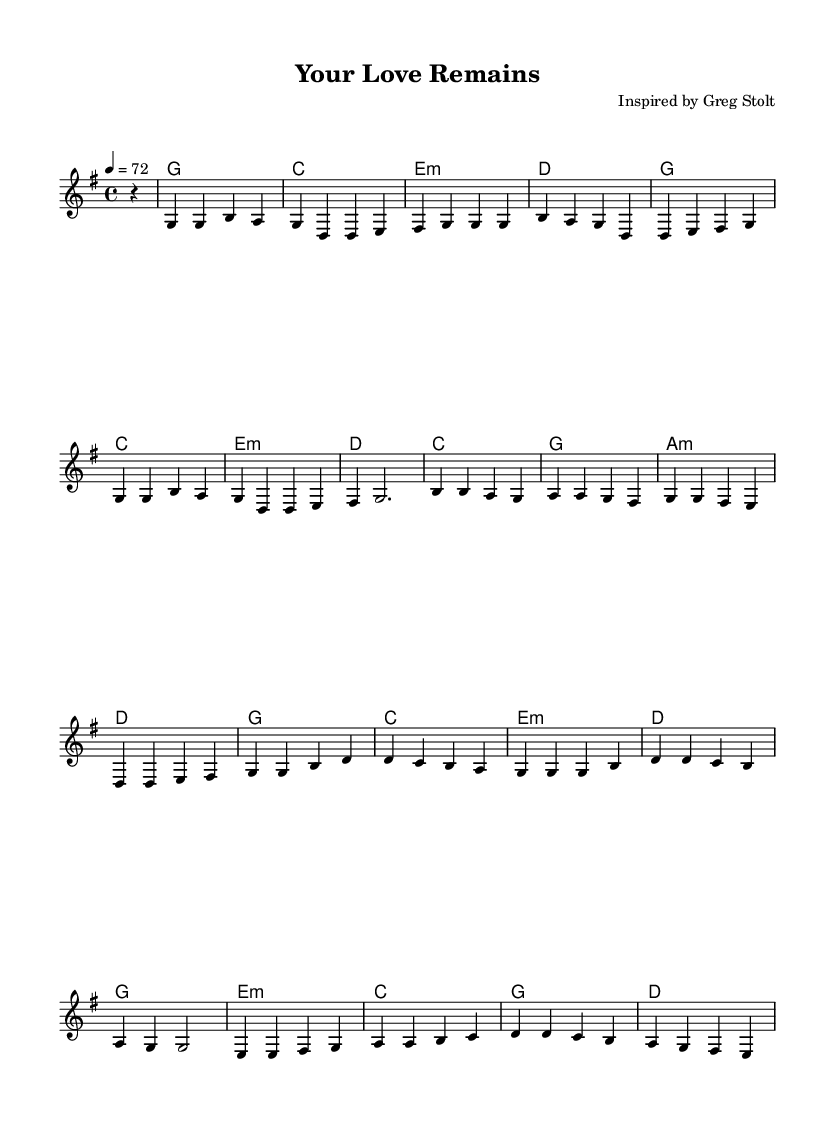What is the key signature of this music? The key signature is indicated at the beginning of the score, which shows that there are no sharps or flats, confirming G major as the key signature.
Answer: G major What is the time signature of this music? The time signature is found next to the key signature, showing the organization of beats in each measure. The numerator (4) indicates that there are four beats per measure, and the denominator (4) indicates that the quarter note gets one beat.
Answer: 4/4 What is the tempo marking for this piece? The tempo marking appears under the global settings and indicates the speed at which the piece should be played. The marking shows that the piece should be played at a pace of 72 beats per minute.
Answer: 72 How many measures are in the verse section? The verse section can be identified by counting the distinct group of musical phrases that fall under the verse markings. After counting, it is determined that there are 8 measures in this section.
Answer: 8 What chord follows the A minor chord in the pre-chorus? The chord progression must be traced in the score, specifically under the pre-chorus section. After following the sequence, it is clear that the chord that follows A minor (a:m) is D major.
Answer: D What is the last chord in the bridge section? To find the last chord in the bridge, one must review the chord sequence for that section, where the musical phrases are laid out. The last chord is revealed to be D major, concluding the bridge.
Answer: D What is the vocal clef used in this music? The vocal clef is indicated at the beginning of the staff section for the lead voice, which helps determine the range of notes for the vocalist. The clef shown is the treble clef, designed for higher vocal parts.
Answer: Treble clef 